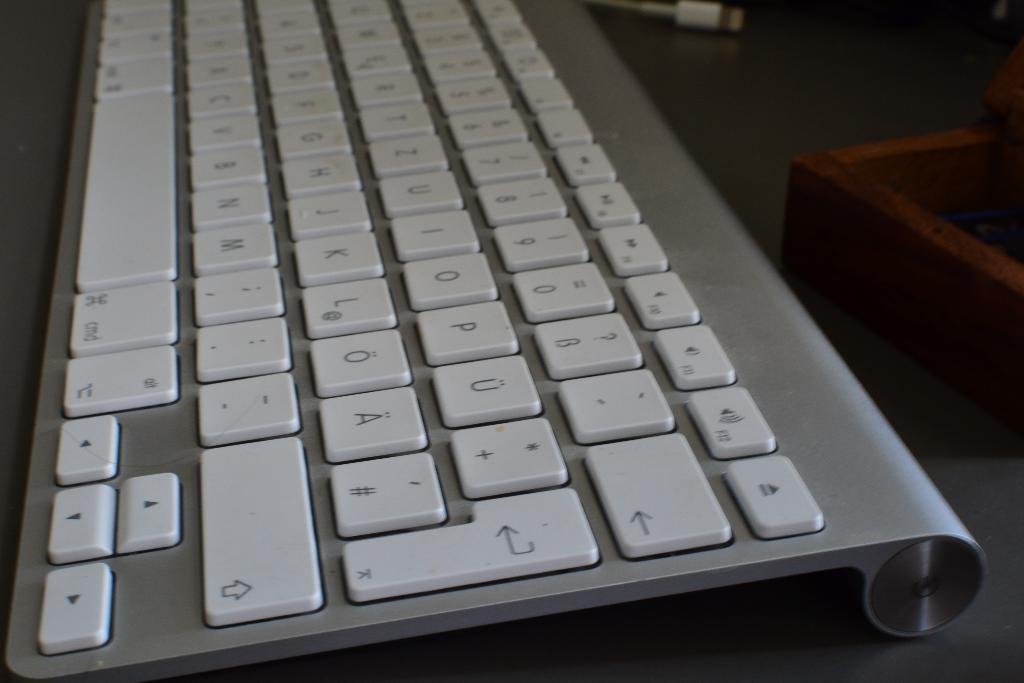<image>
Create a compact narrative representing the image presented. Close up of a keyboard that has the P key between the O and U key. 